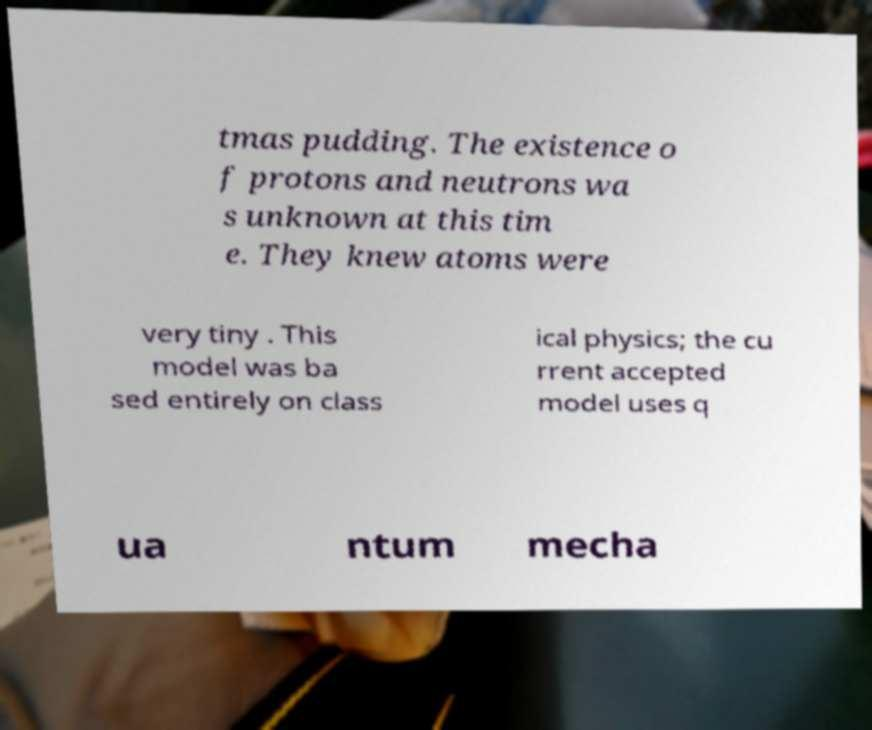What messages or text are displayed in this image? I need them in a readable, typed format. tmas pudding. The existence o f protons and neutrons wa s unknown at this tim e. They knew atoms were very tiny . This model was ba sed entirely on class ical physics; the cu rrent accepted model uses q ua ntum mecha 